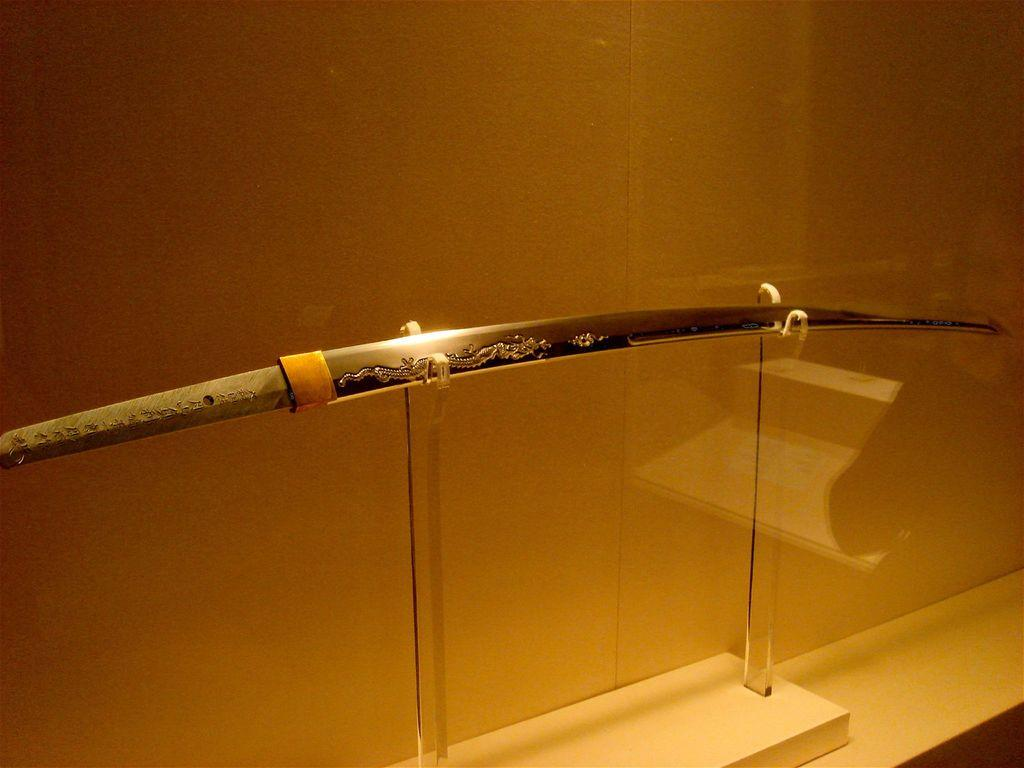What weapon is present in the image? There is a sword in the image. How is the sword displayed in the image? The sword is kept on a stand. What can be seen behind the sword in the image? There is a wall visible behind the sword. How much salt is present on the rock in the image? There is no rock or salt present in the image; it only features a sword on a stand with a wall in the background. 